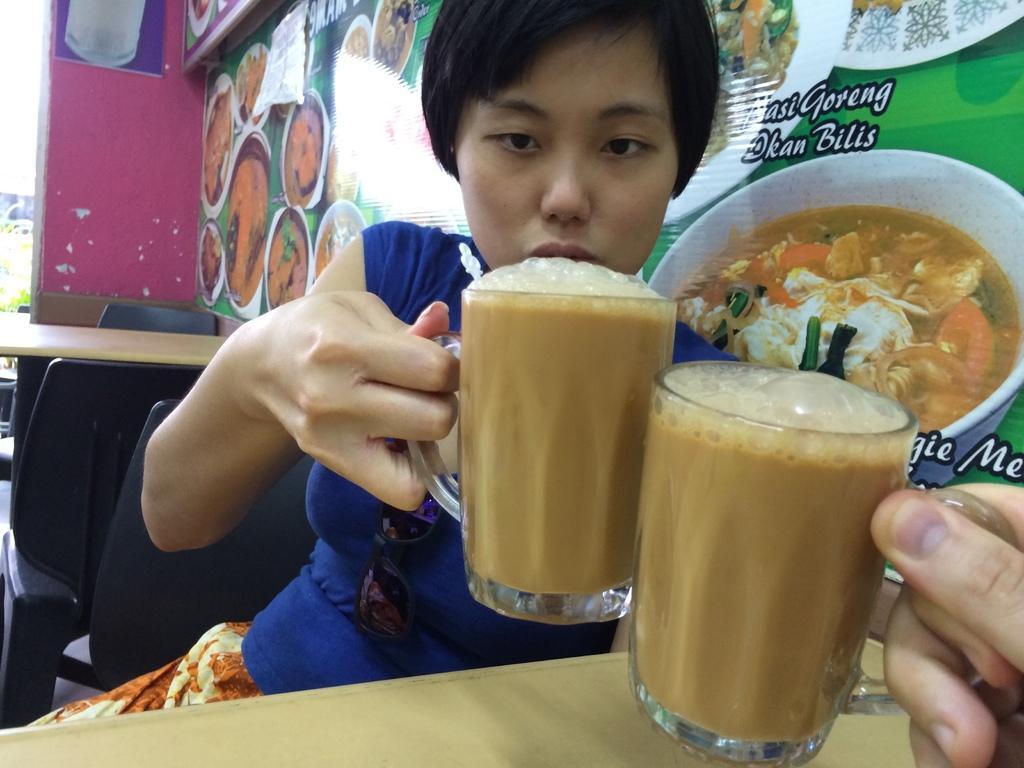How would you summarize this image in a sentence or two? In this image we can see the person sitting on the chair and holding a glass with a drink and we can see there is the other person's hand holding a glass with a drink. And there are tables and chairs. At the back we can see the poster with images attached to the wall. 